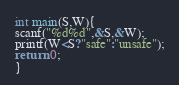Convert code to text. <code><loc_0><loc_0><loc_500><loc_500><_C_>int main(S,W){
scanf("%d%d",&S,&W);
printf(W<S?"safe":"unsafe");
return 0;
}</code> 